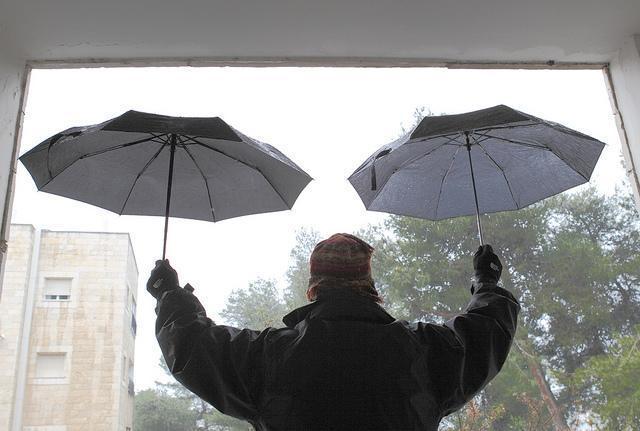How many objects is this person holding?
Give a very brief answer. 2. How many umbrellas can you see?
Give a very brief answer. 2. 